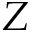<formula> <loc_0><loc_0><loc_500><loc_500>Z</formula> 